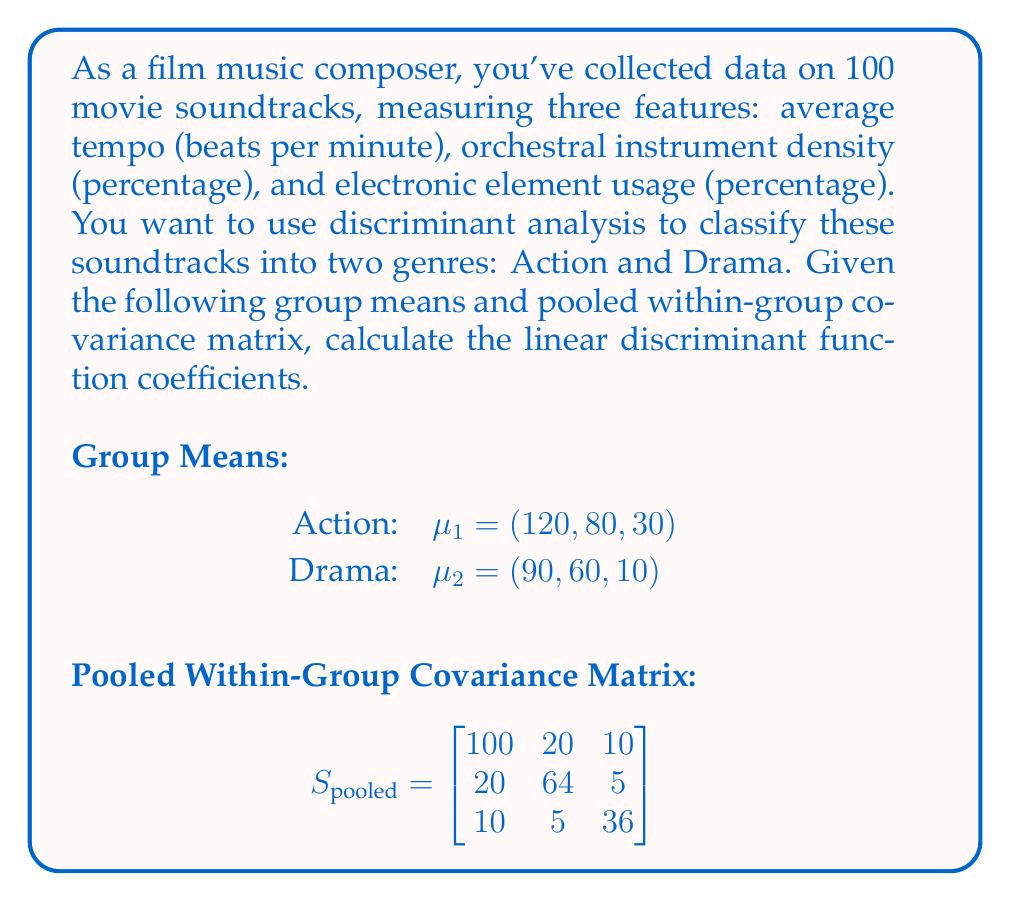Teach me how to tackle this problem. To calculate the linear discriminant function coefficients, we'll follow these steps:

1) The linear discriminant function is given by:
   $$a = S_{pooled}^{-1}(\mu_1 - \mu_2)$$

2) First, we need to find $S_{pooled}^{-1}$. We can use a calculator or computer for this:

   $$S_{pooled}^{-1} = \begin{bmatrix}
   0.0106 & -0.0033 & -0.0028 \\
   -0.0033 & 0.0165 & -0.0017 \\
   -0.0028 & -0.0017 & 0.0285
   \end{bmatrix}$$

3) Next, we calculate $(\mu_1 - \mu_2)$:
   $$\mu_1 - \mu_2 = (120, 80, 30) - (90, 60, 10) = (30, 20, 20)$$

4) Now, we multiply $S_{pooled}^{-1}$ by $(\mu_1 - \mu_2)$:

   $$\begin{bmatrix}
   0.0106 & -0.0033 & -0.0028 \\
   -0.0033 & 0.0165 & -0.0017 \\
   -0.0028 & -0.0017 & 0.0285
   \end{bmatrix} \begin{pmatrix} 30 \\ 20 \\ 20 \end{pmatrix}$$

5) Performing the matrix multiplication:

   $$a_1 = 0.0106(30) + (-0.0033)(20) + (-0.0028)(20) = 0.2180$$
   $$a_2 = (-0.0033)(30) + 0.0165(20) + (-0.0017)(20) = 0.2290$$
   $$a_3 = (-0.0028)(30) + (-0.0017)(20) + 0.0285(20) = 0.4820$$

Therefore, the linear discriminant function coefficients are $a = (0.2180, 0.2290, 0.4820)$.
Answer: $(0.2180, 0.2290, 0.4820)$ 